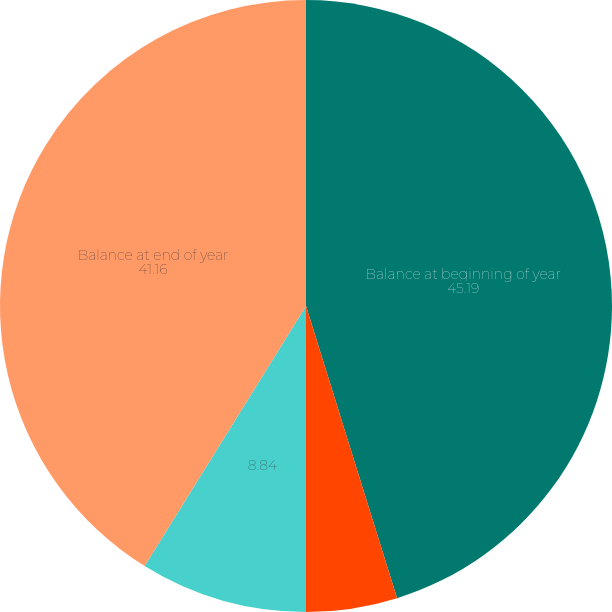<chart> <loc_0><loc_0><loc_500><loc_500><pie_chart><fcel>Balance at beginning of year<fcel>Depreciation for year<fcel>Unnamed: 2<fcel>Balance at end of year<nl><fcel>45.19%<fcel>4.81%<fcel>8.84%<fcel>41.16%<nl></chart> 